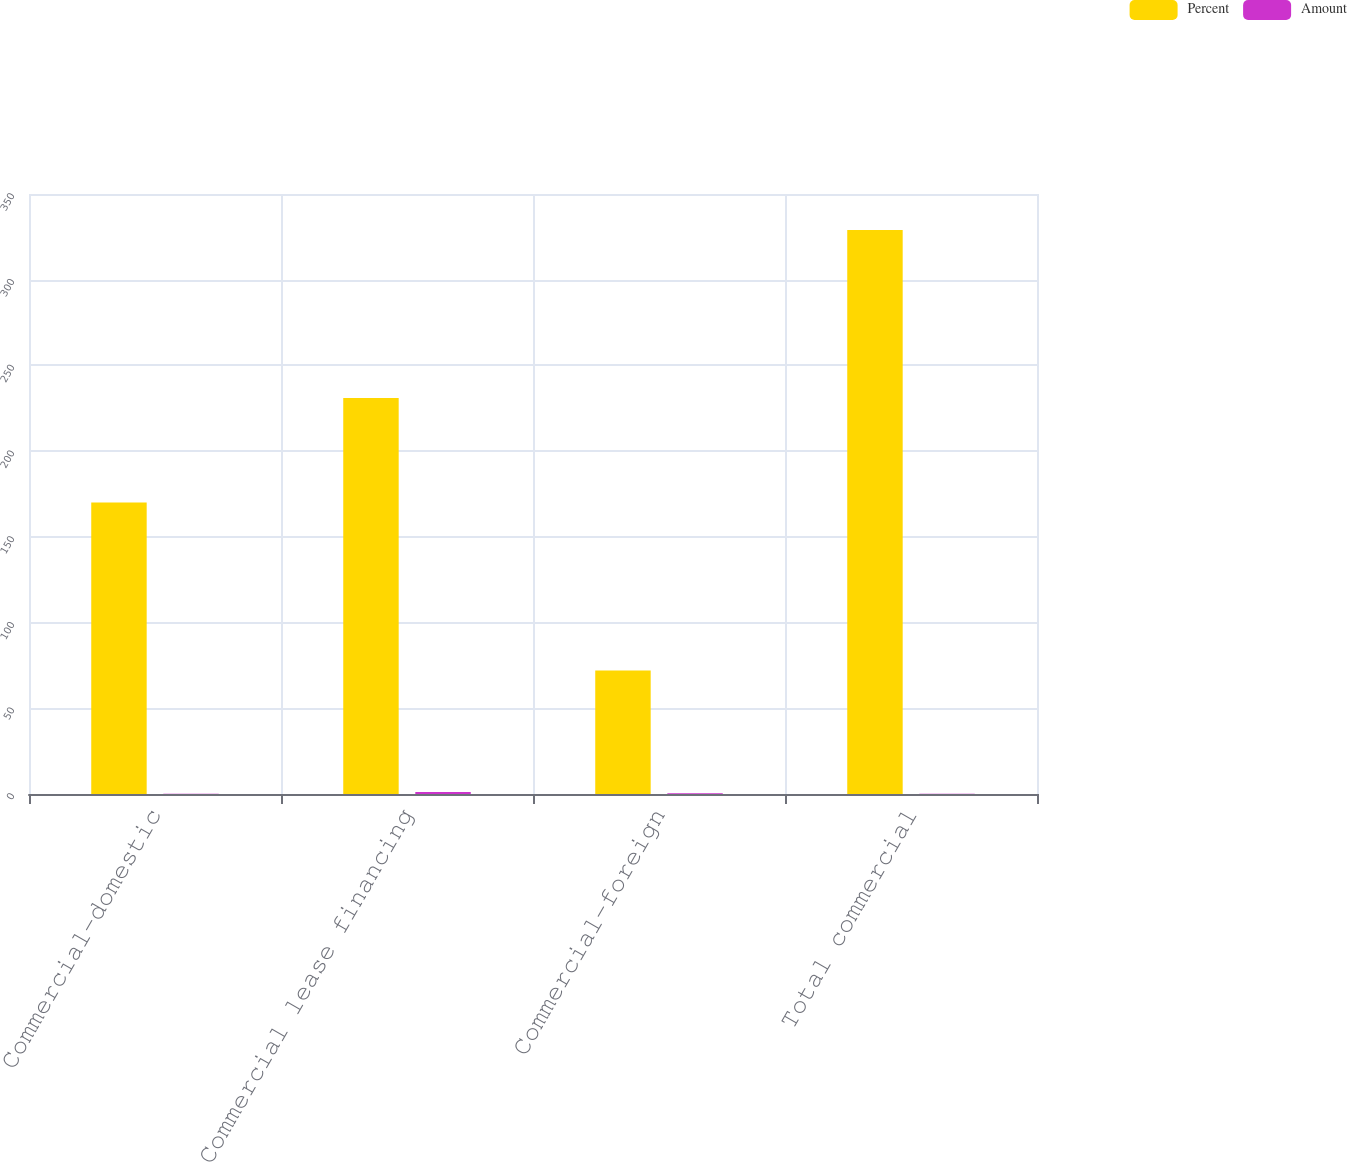Convert chart. <chart><loc_0><loc_0><loc_500><loc_500><stacked_bar_chart><ecel><fcel>Commercial-domestic<fcel>Commercial lease financing<fcel>Commercial-foreign<fcel>Total commercial<nl><fcel>Percent<fcel>170<fcel>231<fcel>72<fcel>329<nl><fcel>Amount<fcel>0.13<fcel>1.13<fcel>0.39<fcel>0.16<nl></chart> 